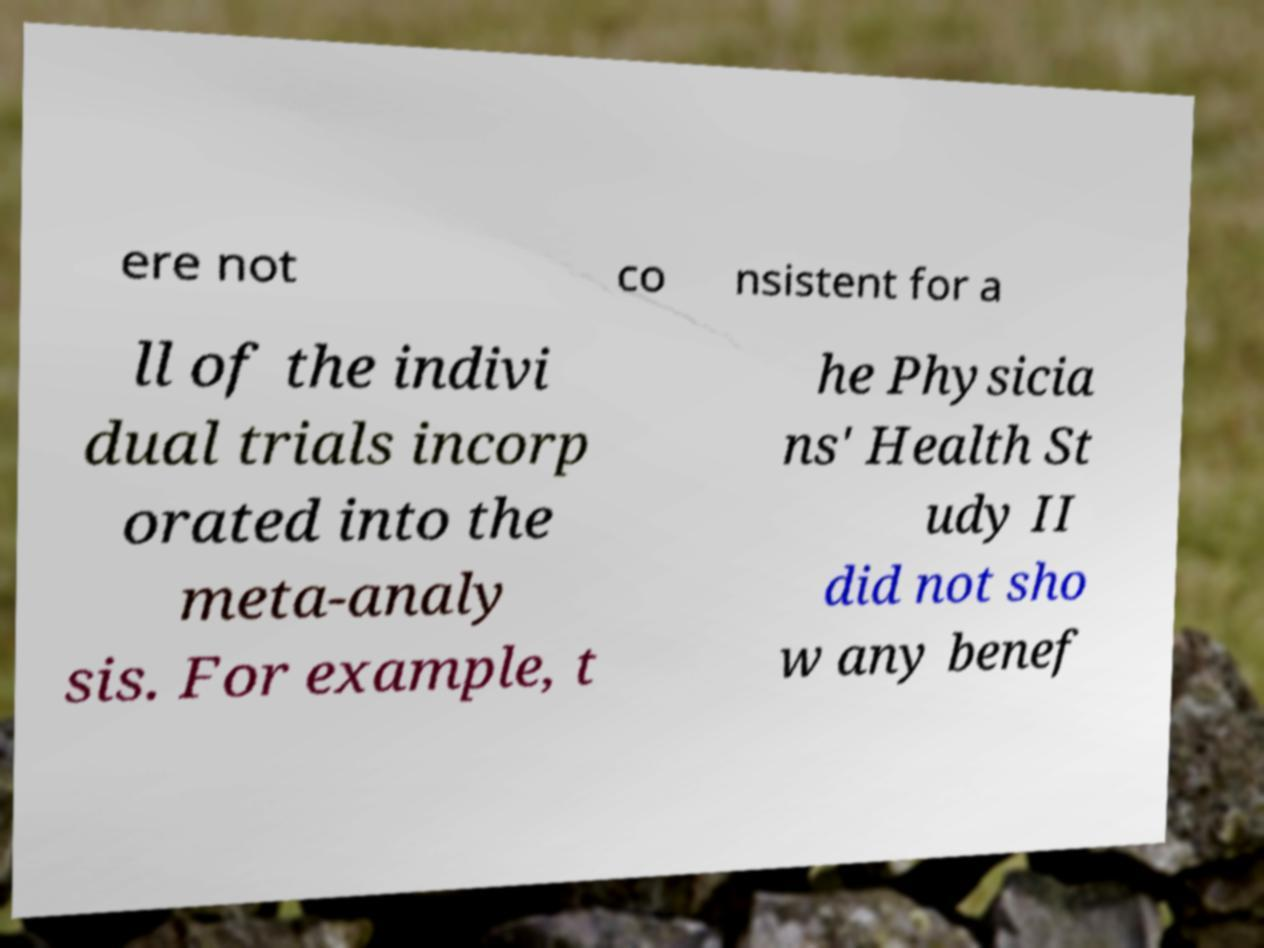There's text embedded in this image that I need extracted. Can you transcribe it verbatim? ere not co nsistent for a ll of the indivi dual trials incorp orated into the meta-analy sis. For example, t he Physicia ns' Health St udy II did not sho w any benef 